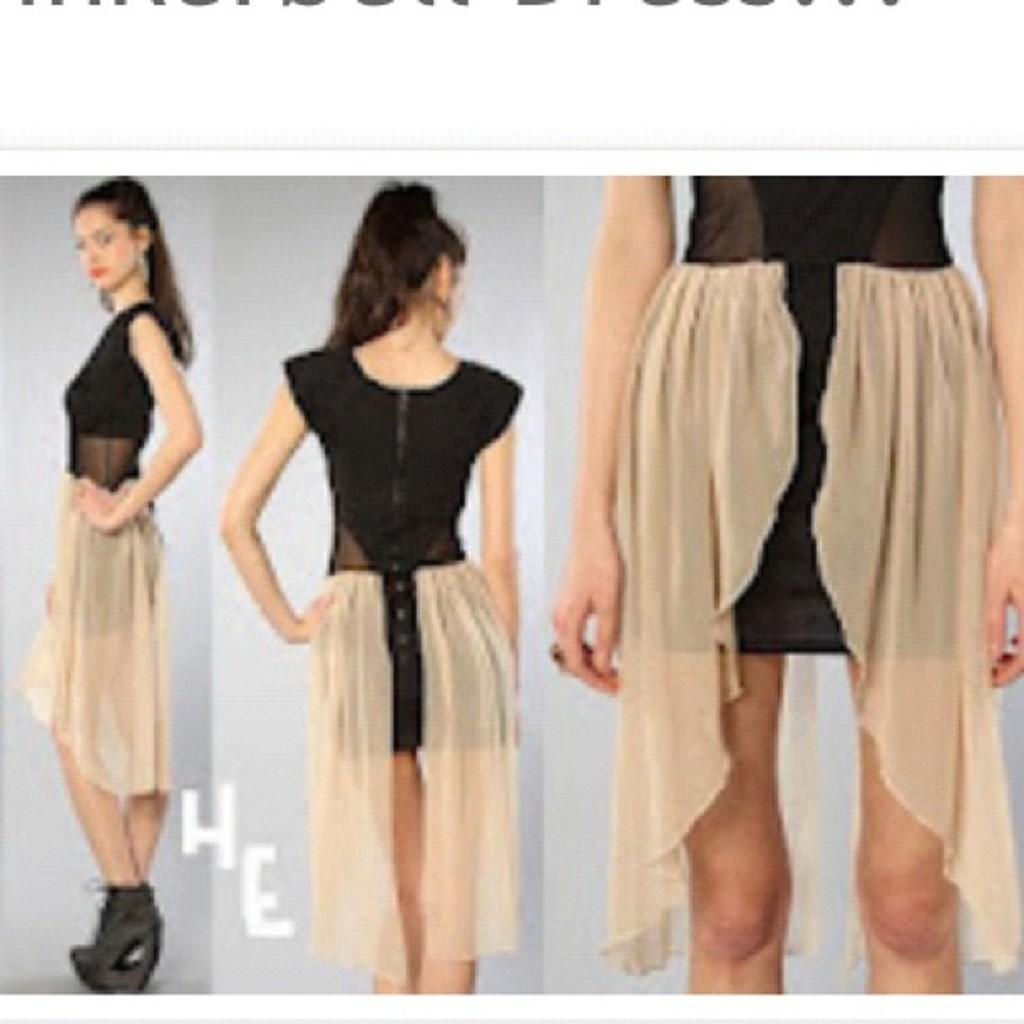Can you describe this image briefly? In this picture we can observe three images of woman wearing blue and green color dress. The background is in grey color. 